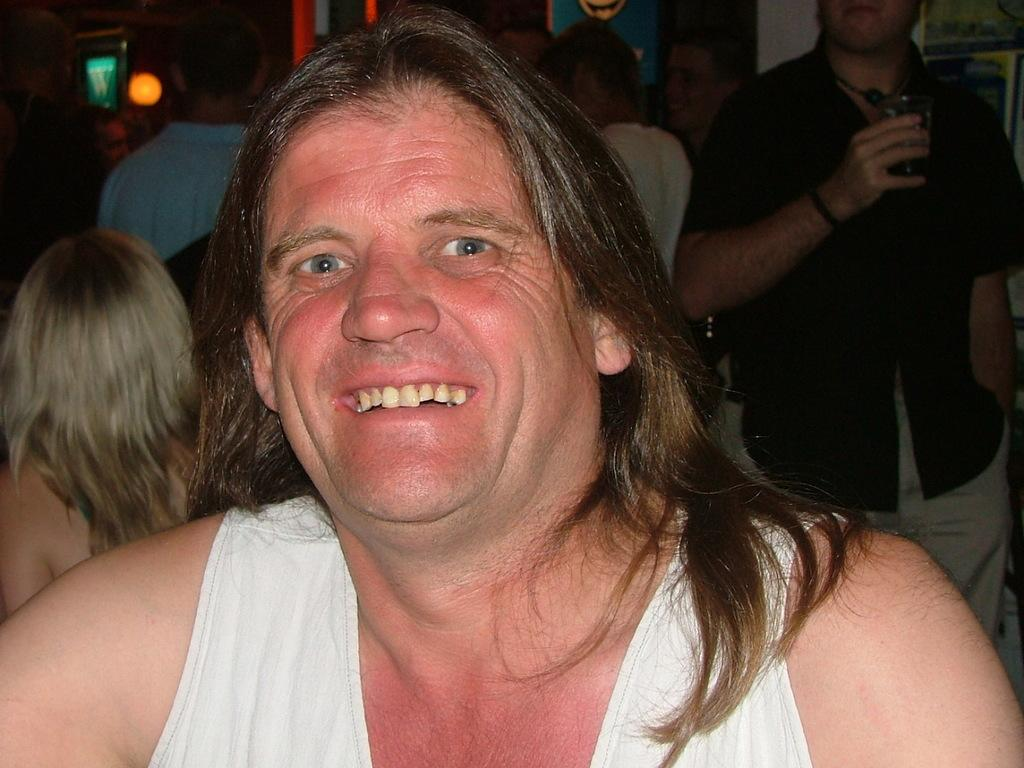Who is the main subject in the image? There is a man in the image. What is the man doing in the image? The man is smiling. What can be seen in the background of the image? There are many people in the background of the image, and the background is dark. Can you describe the man standing to the right of the image? The man on the right is holding a glass in his hand. What type of underwear is the man wearing in the image? There is no information about the man's underwear in the image, so it cannot be determined. 